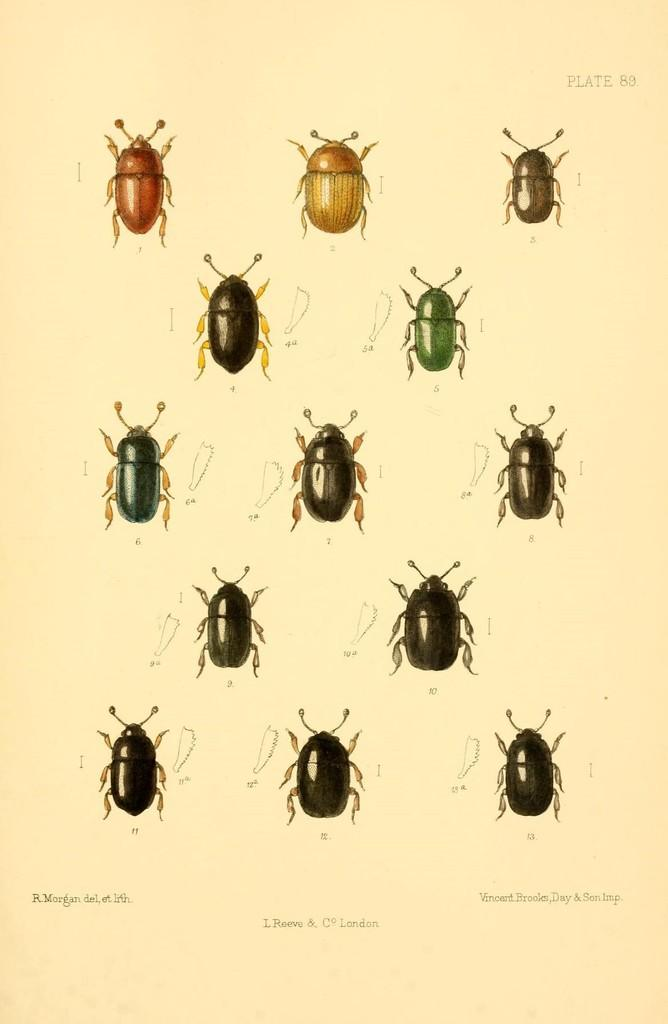What type of creatures can be seen in the image? There are insects in the image. What color is the background of the image? The background of the image is cream-colored. Is there any text visible in the image? Yes, there is text written on the background. How many planes can be seen flying in the image? There are no planes visible in the image; it features insects and text on a cream-colored background. What type of skin is visible on the insects in the image? The image does not show the skin of the insects; it only shows their bodies and wings. 